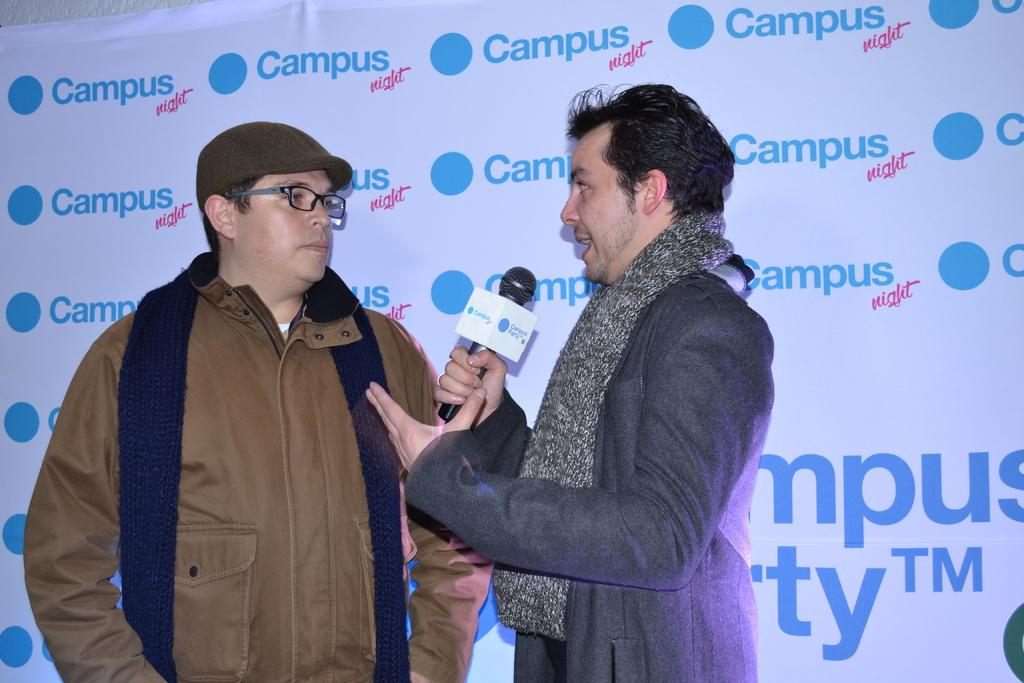How many people are present in the image? There are two people standing in the image. What is the man holding in the image? The man is holding a microphone in the image. What is the man doing in the image? The man is explaining something in the image. What can be seen in the background of the image? There is a banner in the background of the image. What type of beef is being served at the event depicted in the image? There is no mention of beef or any event in the image; it simply shows two people, one of whom is holding a microphone and explaining something. 